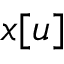<formula> <loc_0><loc_0><loc_500><loc_500>x [ u ]</formula> 